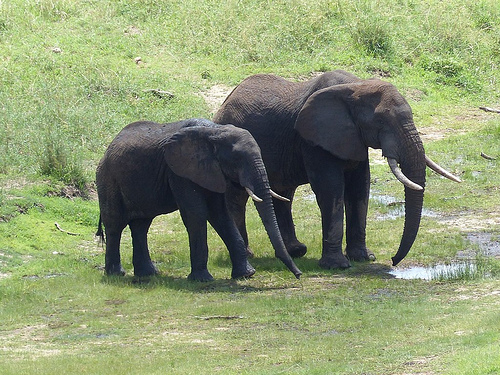What is the animal in front of the grassy hill called? The animal in front of the grassy hill is an elephant. 